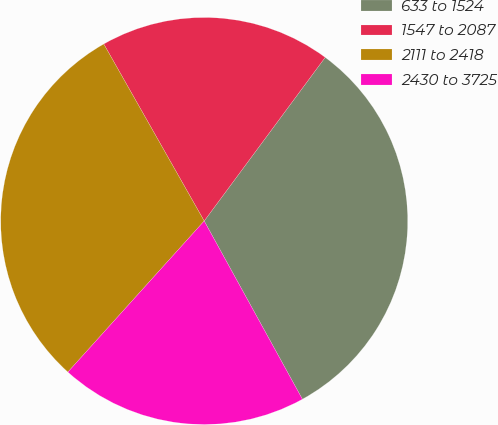Convert chart. <chart><loc_0><loc_0><loc_500><loc_500><pie_chart><fcel>633 to 1524<fcel>1547 to 2087<fcel>2111 to 2418<fcel>2430 to 3725<nl><fcel>31.85%<fcel>18.35%<fcel>30.1%<fcel>19.7%<nl></chart> 